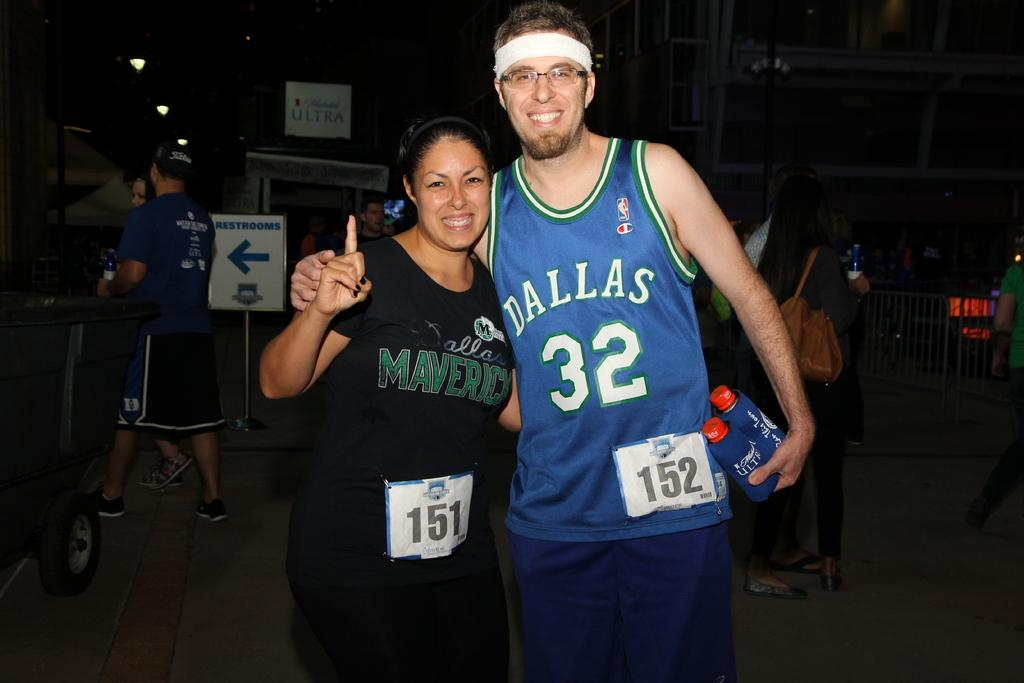<image>
Share a concise interpretation of the image provided. A man wearing a Dallas jersey is posing with a woman. 